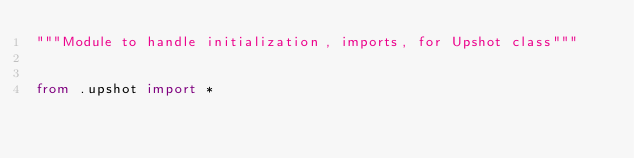Convert code to text. <code><loc_0><loc_0><loc_500><loc_500><_Python_>"""Module to handle initialization, imports, for Upshot class"""


from .upshot import *
</code> 